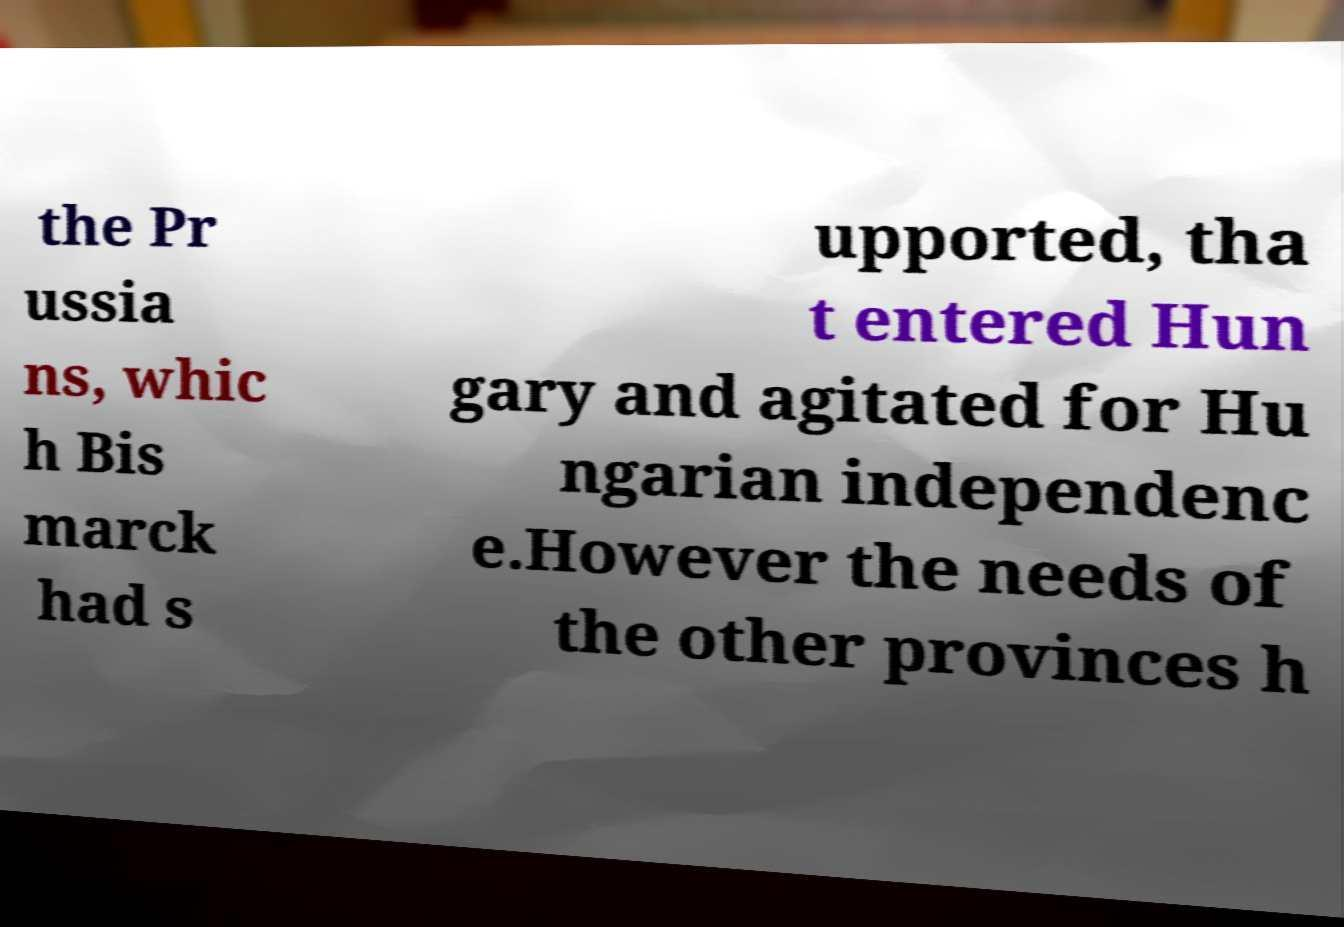Could you extract and type out the text from this image? the Pr ussia ns, whic h Bis marck had s upported, tha t entered Hun gary and agitated for Hu ngarian independenc e.However the needs of the other provinces h 